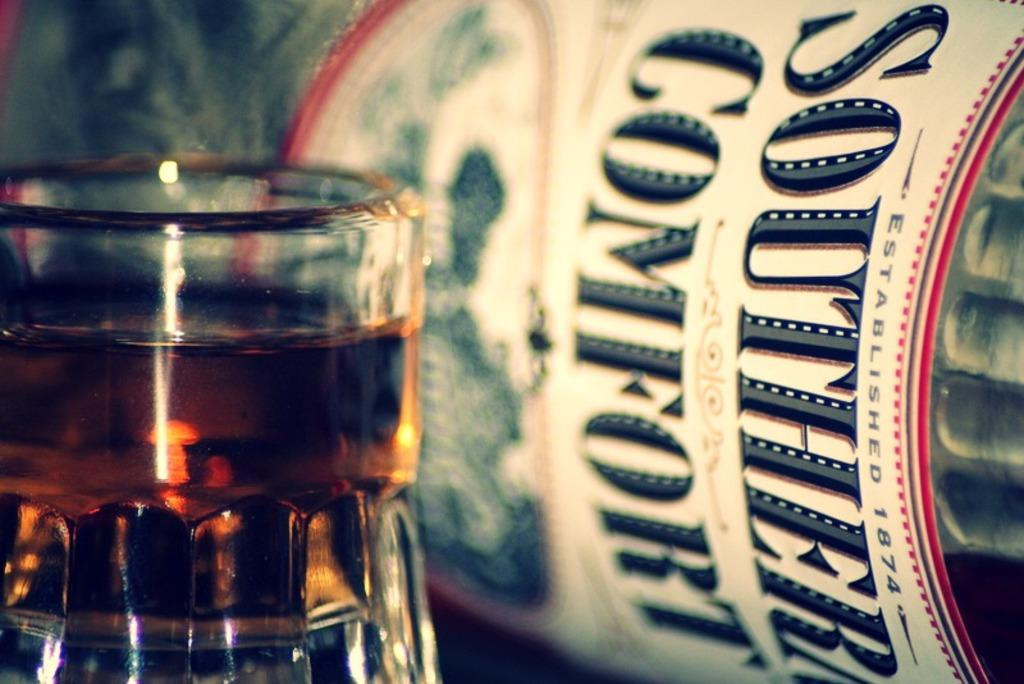<image>
Give a short and clear explanation of the subsequent image. A bottle of SOUTHERN COMFORT sits on its side behind a short glass filled with liquid. 